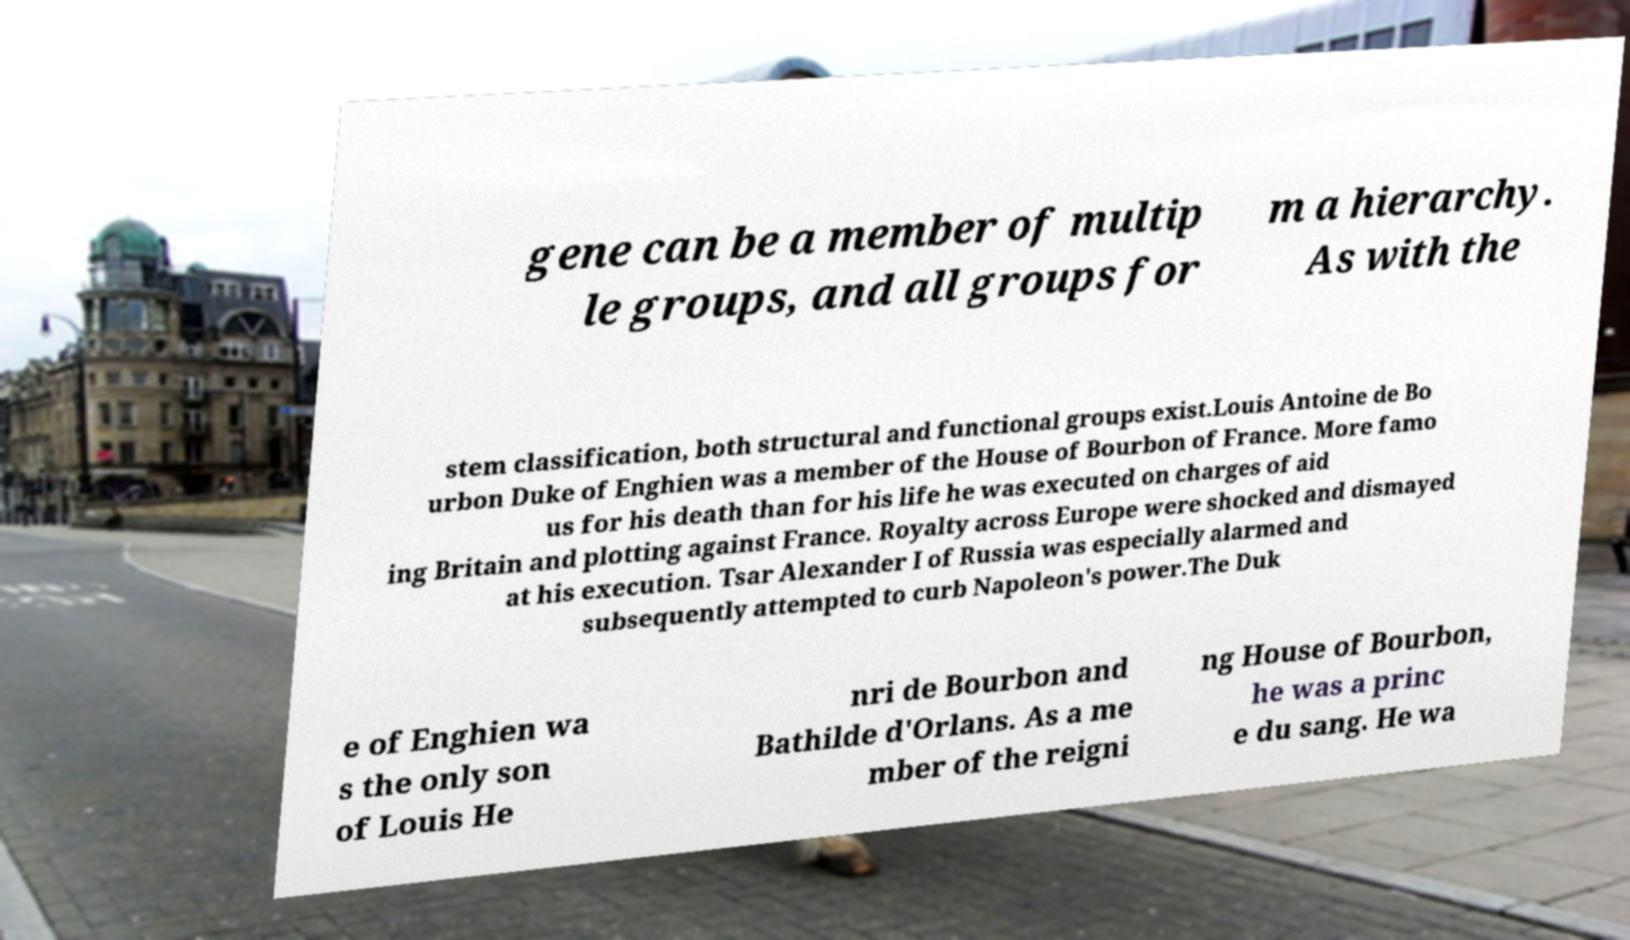Could you assist in decoding the text presented in this image and type it out clearly? gene can be a member of multip le groups, and all groups for m a hierarchy. As with the stem classification, both structural and functional groups exist.Louis Antoine de Bo urbon Duke of Enghien was a member of the House of Bourbon of France. More famo us for his death than for his life he was executed on charges of aid ing Britain and plotting against France. Royalty across Europe were shocked and dismayed at his execution. Tsar Alexander I of Russia was especially alarmed and subsequently attempted to curb Napoleon's power.The Duk e of Enghien wa s the only son of Louis He nri de Bourbon and Bathilde d'Orlans. As a me mber of the reigni ng House of Bourbon, he was a princ e du sang. He wa 